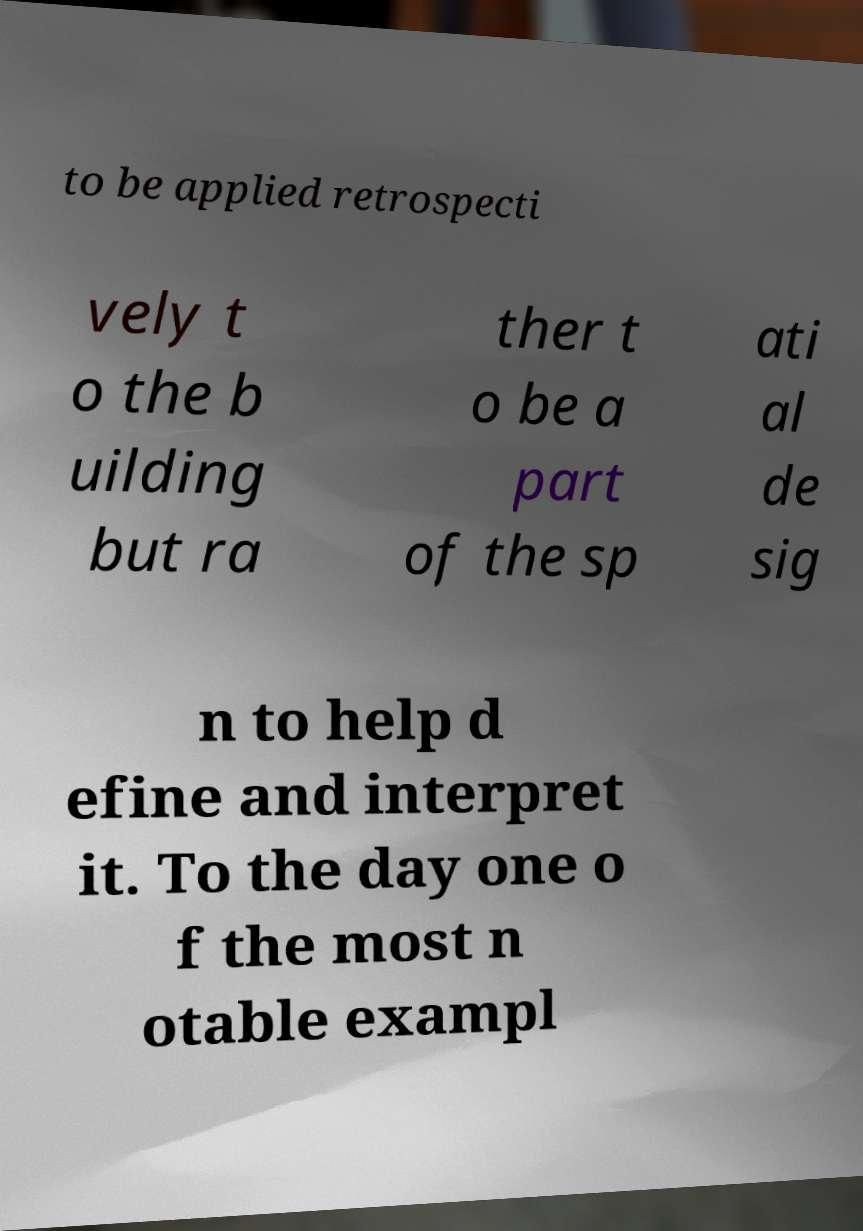I need the written content from this picture converted into text. Can you do that? to be applied retrospecti vely t o the b uilding but ra ther t o be a part of the sp ati al de sig n to help d efine and interpret it. To the day one o f the most n otable exampl 